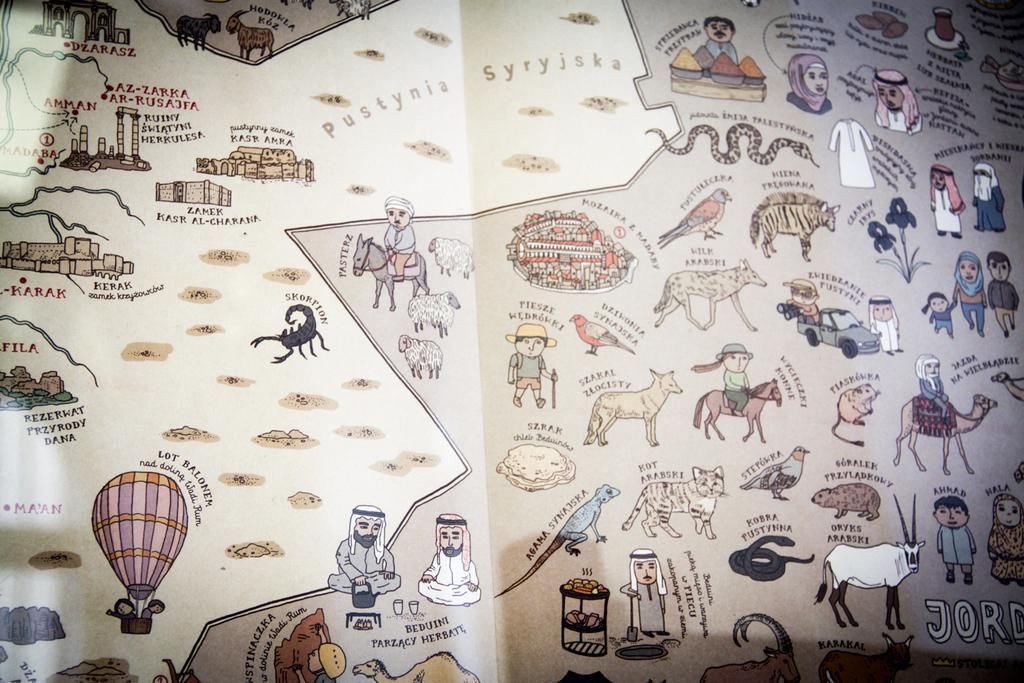What is the main subject of the poster in the image? The poster has animated images of persons, animals, birds, buildings, and other objects. What type of images are featured on the poster? The poster has animated images of persons, animals, birds, buildings, and other objects. Are there any texts on the poster? Yes, there are texts on the poster. What theory is being discussed by the stranger in the image? There is no stranger present in the image, and therefore no discussion or theory can be observed. How does the breath of the animals affect the animated images on the poster? The poster is a static image and does not depict the breath of any animals, so this question cannot be answered. 